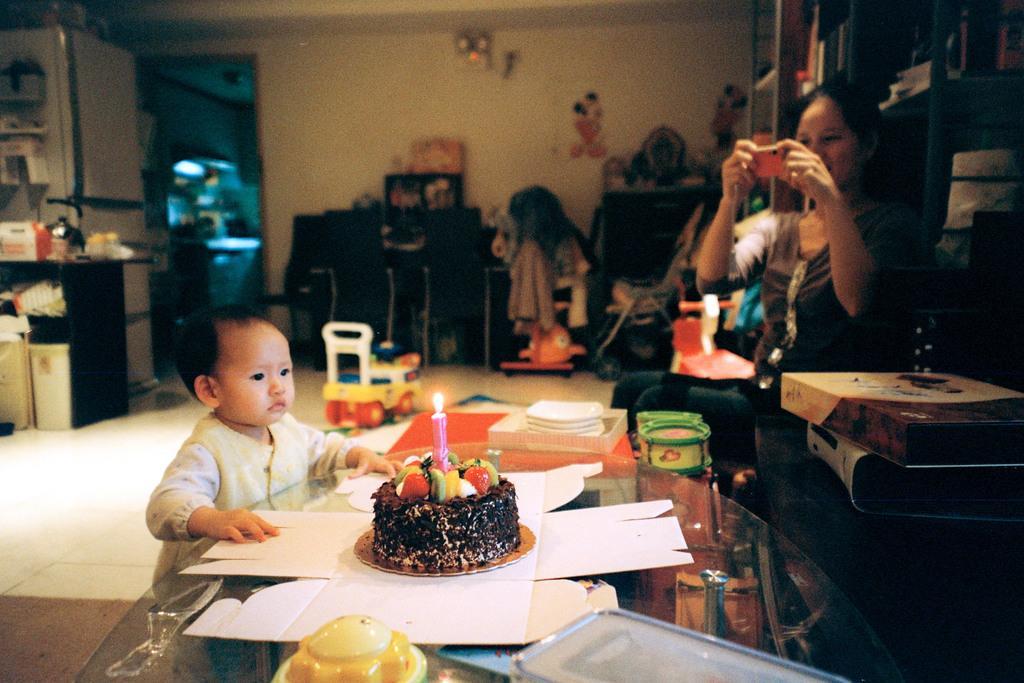Please provide a concise description of this image. In this image i can see a woman sitting and holding a wall in front of a woman there is a kid, a cake on a table at the back ground i can see a cup board and a wall. 